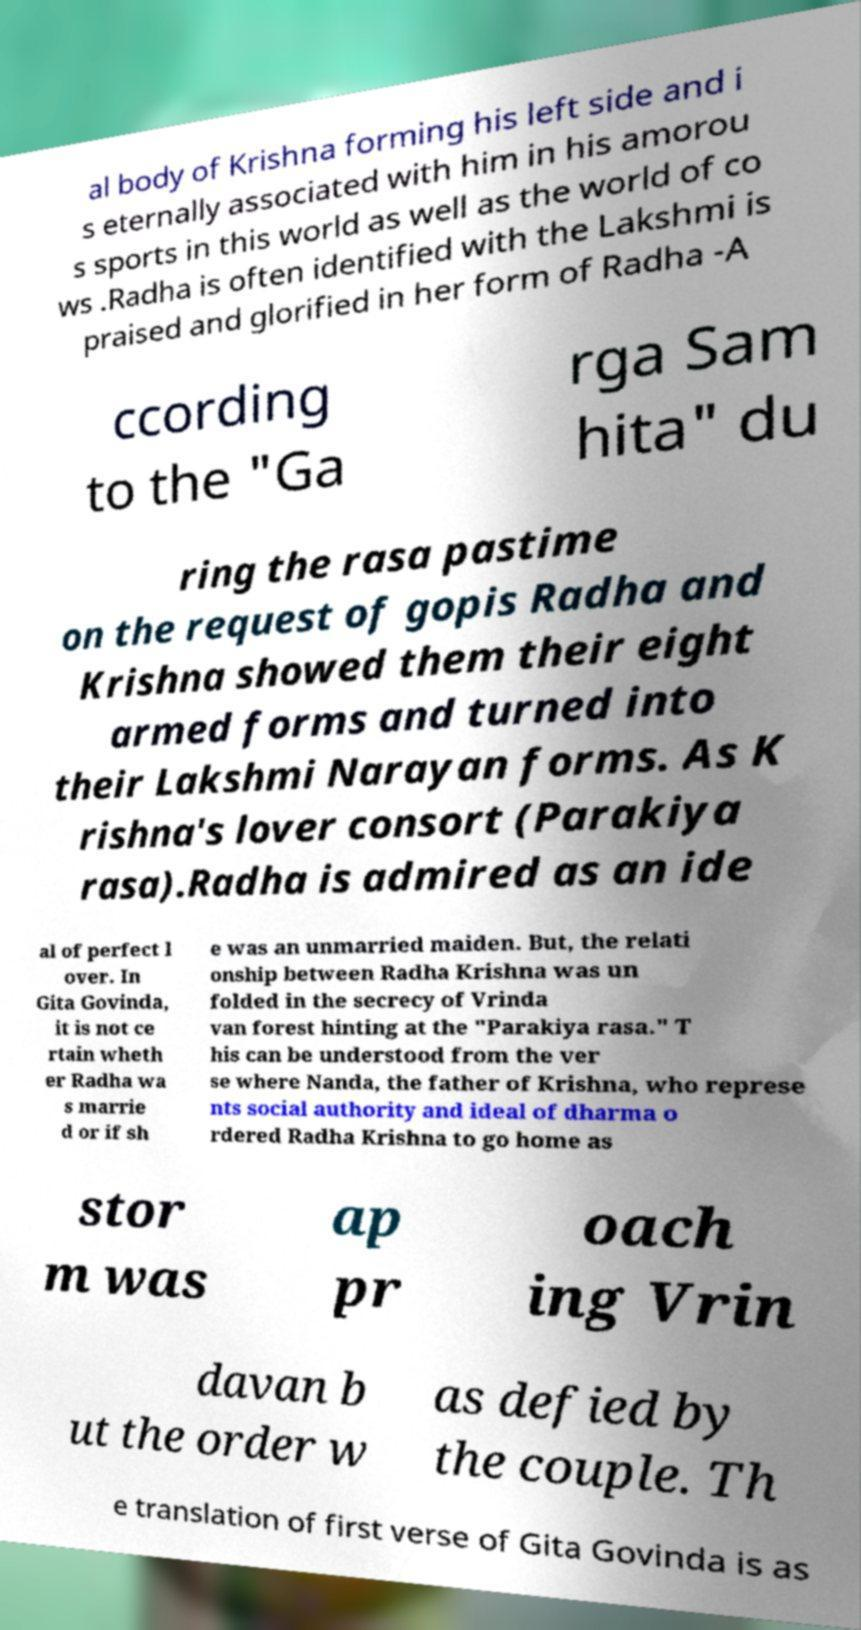There's text embedded in this image that I need extracted. Can you transcribe it verbatim? al body of Krishna forming his left side and i s eternally associated with him in his amorou s sports in this world as well as the world of co ws .Radha is often identified with the Lakshmi is praised and glorified in her form of Radha -A ccording to the "Ga rga Sam hita" du ring the rasa pastime on the request of gopis Radha and Krishna showed them their eight armed forms and turned into their Lakshmi Narayan forms. As K rishna's lover consort (Parakiya rasa).Radha is admired as an ide al of perfect l over. In Gita Govinda, it is not ce rtain wheth er Radha wa s marrie d or if sh e was an unmarried maiden. But, the relati onship between Radha Krishna was un folded in the secrecy of Vrinda van forest hinting at the "Parakiya rasa." T his can be understood from the ver se where Nanda, the father of Krishna, who represe nts social authority and ideal of dharma o rdered Radha Krishna to go home as stor m was ap pr oach ing Vrin davan b ut the order w as defied by the couple. Th e translation of first verse of Gita Govinda is as 